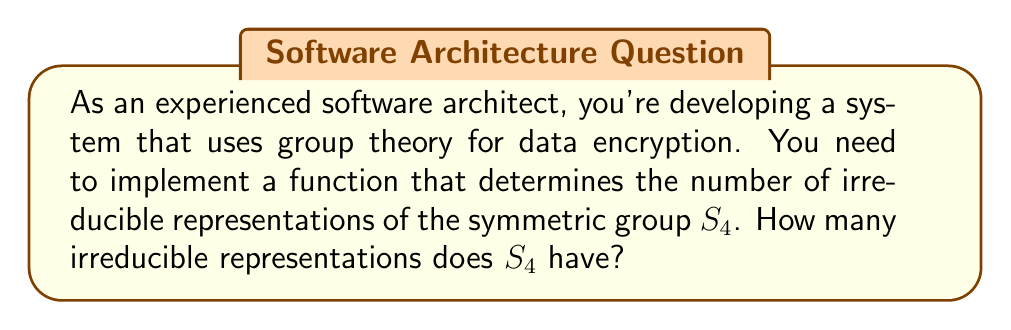Can you solve this math problem? To determine the number of irreducible representations of $S_4$, we can follow these steps:

1) Recall that the number of irreducible representations of a finite group is equal to the number of conjugacy classes in that group.

2) In $S_4$, the conjugacy classes are determined by cycle types. Let's enumerate them:

   - (1,1,1,1): identity permutation
   - (2,1,1): transpositions
   - (2,2): product of two disjoint transpositions
   - (3,1): 3-cycles
   - (4): 4-cycles

3) Each of these cycle types corresponds to a unique conjugacy class in $S_4$.

4) Count the number of conjugacy classes: we have 5 distinct cycle types, so there are 5 conjugacy classes in $S_4$.

5) Therefore, $S_4$ has 5 irreducible representations.

As a software architect, you can use this information to design your encryption function to utilize these 5 irreducible representations for enhanced security and efficiency in your system.
Answer: 5 